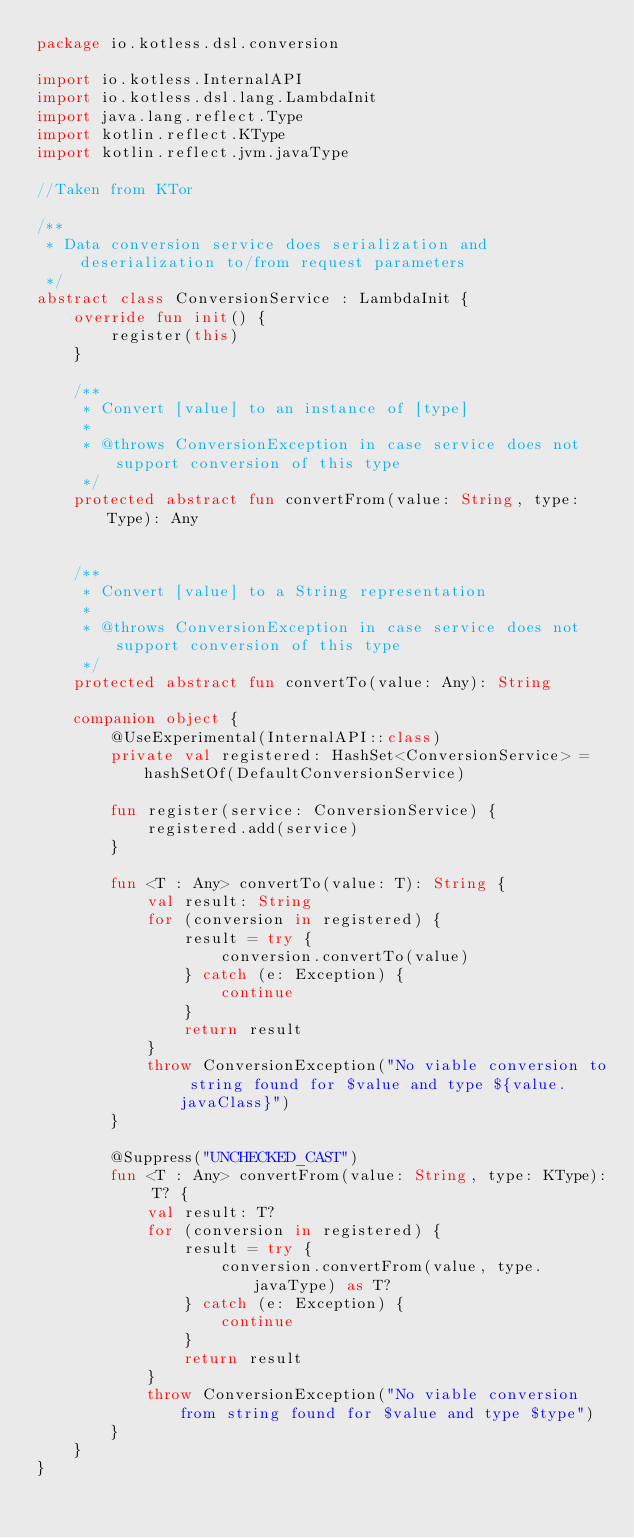<code> <loc_0><loc_0><loc_500><loc_500><_Kotlin_>package io.kotless.dsl.conversion

import io.kotless.InternalAPI
import io.kotless.dsl.lang.LambdaInit
import java.lang.reflect.Type
import kotlin.reflect.KType
import kotlin.reflect.jvm.javaType

//Taken from KTor

/**
 * Data conversion service does serialization and deserialization to/from request parameters
 */
abstract class ConversionService : LambdaInit {
    override fun init() {
        register(this)
    }

    /**
     * Convert [value] to an instance of [type]
     *
     * @throws ConversionException in case service does not support conversion of this type
     */
    protected abstract fun convertFrom(value: String, type: Type): Any


    /**
     * Convert [value] to a String representation
     *
     * @throws ConversionException in case service does not support conversion of this type
     */
    protected abstract fun convertTo(value: Any): String

    companion object {
        @UseExperimental(InternalAPI::class)
        private val registered: HashSet<ConversionService> = hashSetOf(DefaultConversionService)

        fun register(service: ConversionService) {
            registered.add(service)
        }

        fun <T : Any> convertTo(value: T): String {
            val result: String
            for (conversion in registered) {
                result = try {
                    conversion.convertTo(value)
                } catch (e: Exception) {
                    continue
                }
                return result
            }
            throw ConversionException("No viable conversion to string found for $value and type ${value.javaClass}")
        }

        @Suppress("UNCHECKED_CAST")
        fun <T : Any> convertFrom(value: String, type: KType): T? {
            val result: T?
            for (conversion in registered) {
                result = try {
                    conversion.convertFrom(value, type.javaType) as T?
                } catch (e: Exception) {
                    continue
                }
                return result
            }
            throw ConversionException("No viable conversion from string found for $value and type $type")
        }
    }
}

</code> 